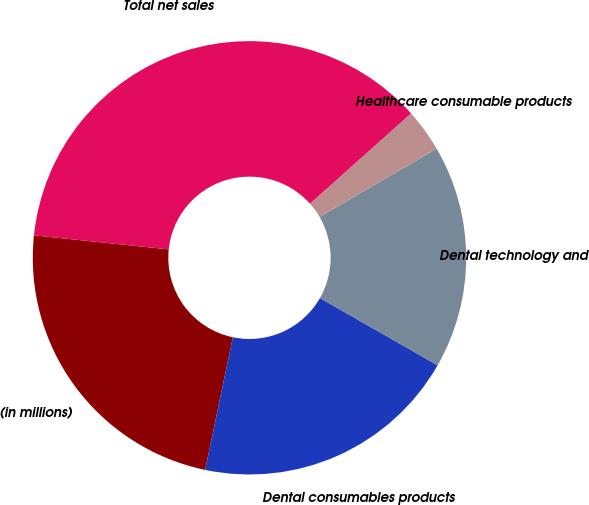<chart> <loc_0><loc_0><loc_500><loc_500><pie_chart><fcel>(in millions)<fcel>Dental consumables products<fcel>Dental technology and<fcel>Healthcare consumable products<fcel>Total net sales<nl><fcel>23.37%<fcel>20.02%<fcel>16.66%<fcel>3.21%<fcel>36.74%<nl></chart> 